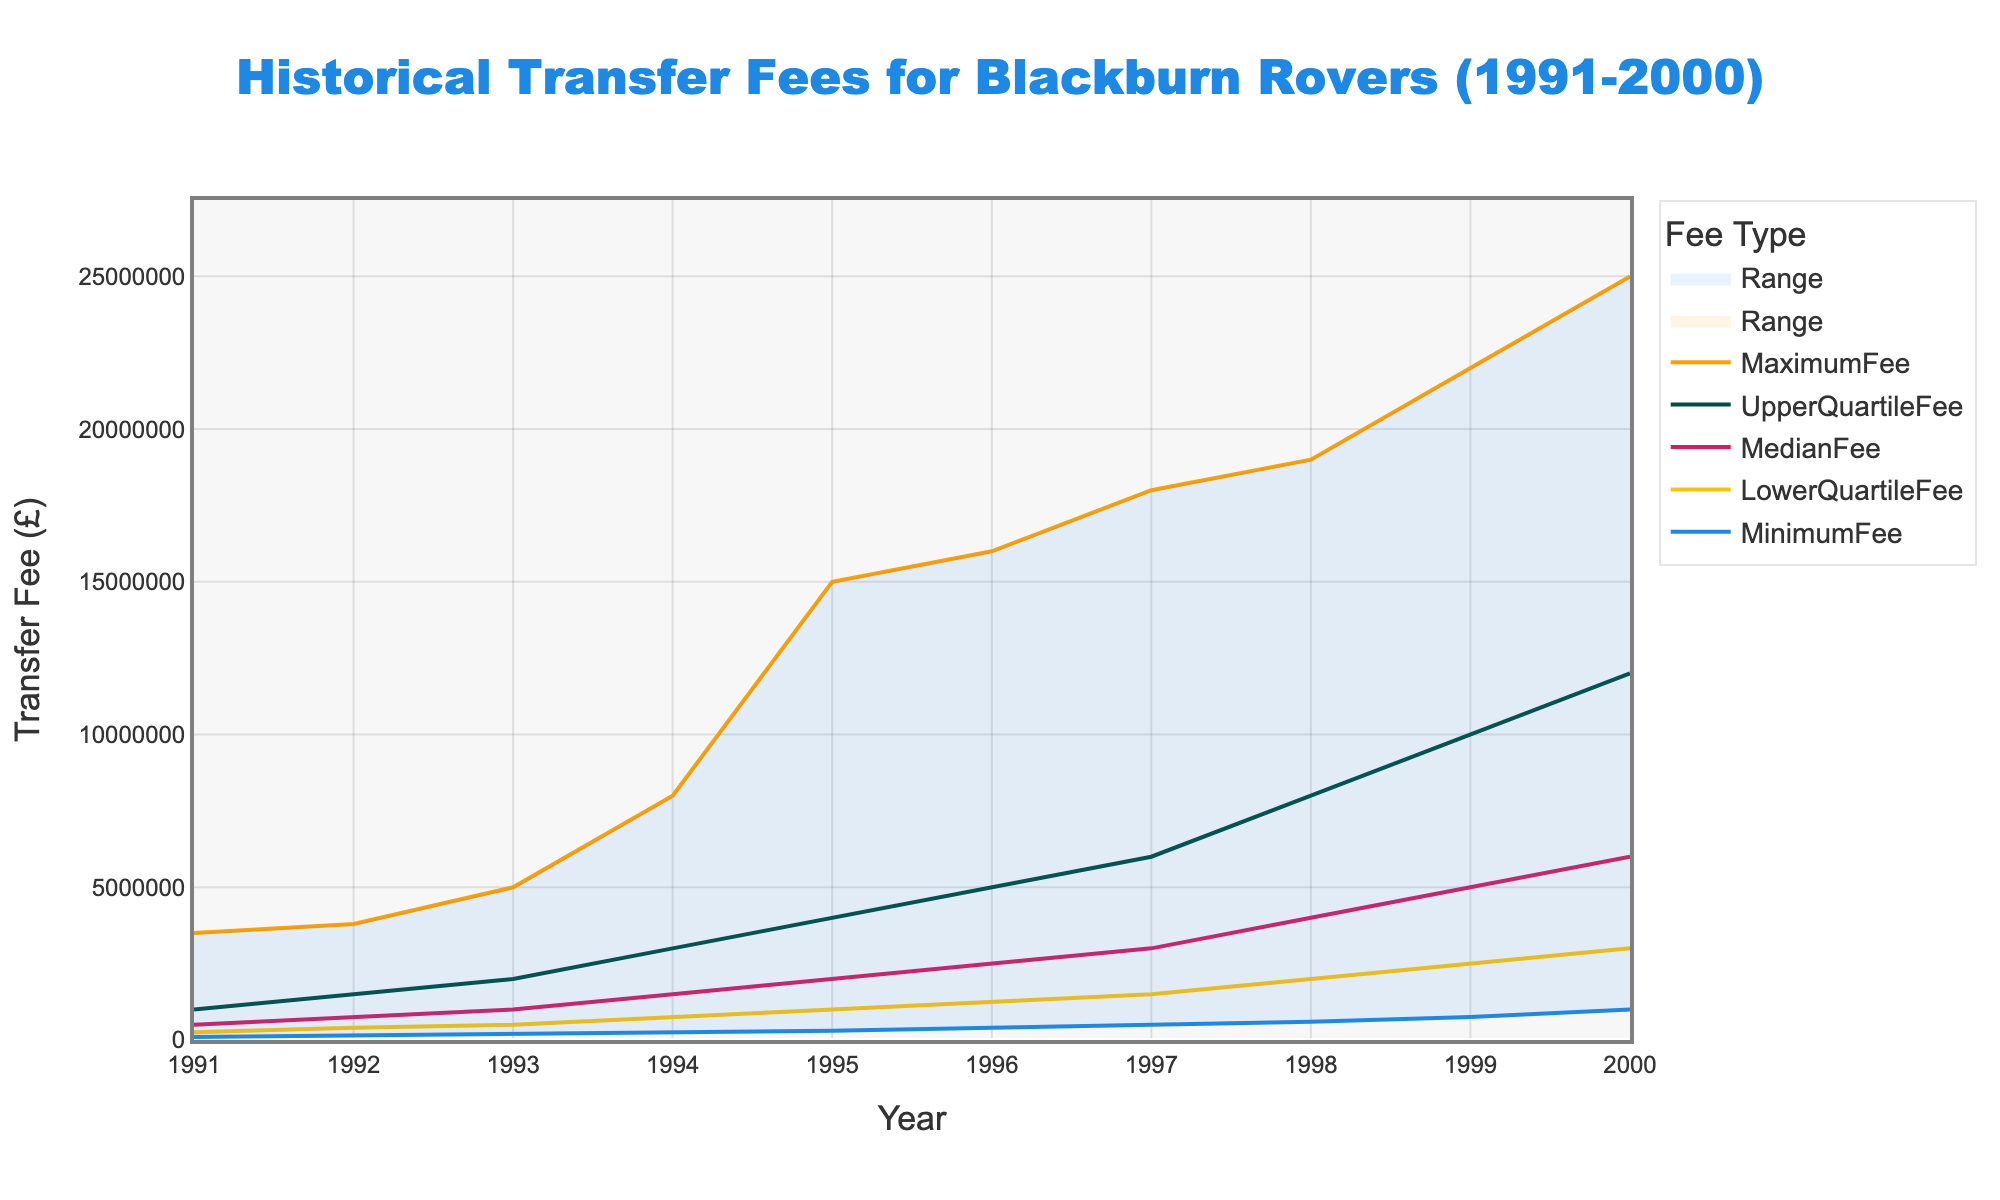what is the title of the plot? The title of the plot is located at the top and is typically the largest text. For this figure, the title reads "Historical Transfer Fees for Blackburn Rovers (1991-2000)."
Answer: Historical Transfer Fees for Blackburn Rovers (1991-2000) What is the range of transfer fees in the year 1995? To find the range of transfer fees for 1995, look at the minimum and maximum values for that year shown as the bottom and top lines of the shaded area. For 1995, the MinimumFee is £300,000 and the MaximumFee is £15,000,000. The range is the difference between these values, which is £15,000,000 - £300,000.
Answer: £14,700,000 Which year shows the highest median transfer fee? To determine the year with the highest median transfer fee, trace the median line, which is the middle line in the five lines presented. For each year, the MedianFee in 2000 is £6,000,000, which is the highest observed.
Answer: 2000 How did the lower quartile transfer fee change from 1991 to 1994? Examine the LowerQuartileFee for the years 1991 and 1994. In 1991, the lower quartile fee is £250,000. In 1994, it is £750,000. The change is found by subtracting the 1991 value from the 1994 value: £750,000 - £250,000.
Answer: Increased by £500,000 In which year was the gap between the upper quartile fee and the median fee the largest? To find the year with the largest gap between the upper quartile fee and the median fee, examine the lines for the UpperQuartileFee and MedianFee. Calculate the difference for each year and compare. In 2000, the UpperQuartileFee is £12,000,000 and the MedianFee is £6,000,000. The gap is £12,000,000 - £6,000,000 = £6,000,000, which is the largest.
Answer: 2000 How did transfer fees trend overall from 1991 to 2000? Observing all the lines from 1991 to 2000, there is a general upward trend in all transfer fees, indicated by the increase in all fee types (Minimum, Lower Quartile, Median, Upper Quartile, and Maximum) over the years.
Answer: Upward trend In 1997, which was higher: the minimum fee or the lower quartile fee? Compare the MinimumFee and LowerQuartileFee for the year 1997. The MinimumFee in 1997 is £500,000, and the LowerQuartileFee is £1,500,000. Since £500,000 is less than £1,500,000, the LowerQuartileFee is higher.
Answer: Lower quartile fee What colors are used to represent the MedianFee and MaximumFee lines? Identify the colors of the lines representing the MedianFee and MaximumFee, which are specified in the code. The MedianFee line is colored '#D81B60', which is a pinkish color, and the MaximumFee line is colored '#FFA000', which is an orange color.
Answer: Pinkish color for MedianFee and orange color for MaximumFee What was the maximum transfer fee in 1998? Look at the value for the MaximumFee in the year 1998 at the top of the shaded range for that year. The MaximumFee is displayed as £19,000,000 in 1998.
Answer: £19,000,000 What can be inferred about the spread of transfer fees over the years based on the plot? The spread of transfer fees is reflected in the distance between the minimum and maximum fees each year. From 1991 to 2000, this spread generally increases significantly, indicating a wider range and more variability in transfer fees. The increase in both minimum and maximum values suggests that higher fees became more common over the decade.
Answer: The spread of transfer fees increased over the years 